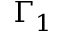Convert formula to latex. <formula><loc_0><loc_0><loc_500><loc_500>\Gamma _ { 1 }</formula> 